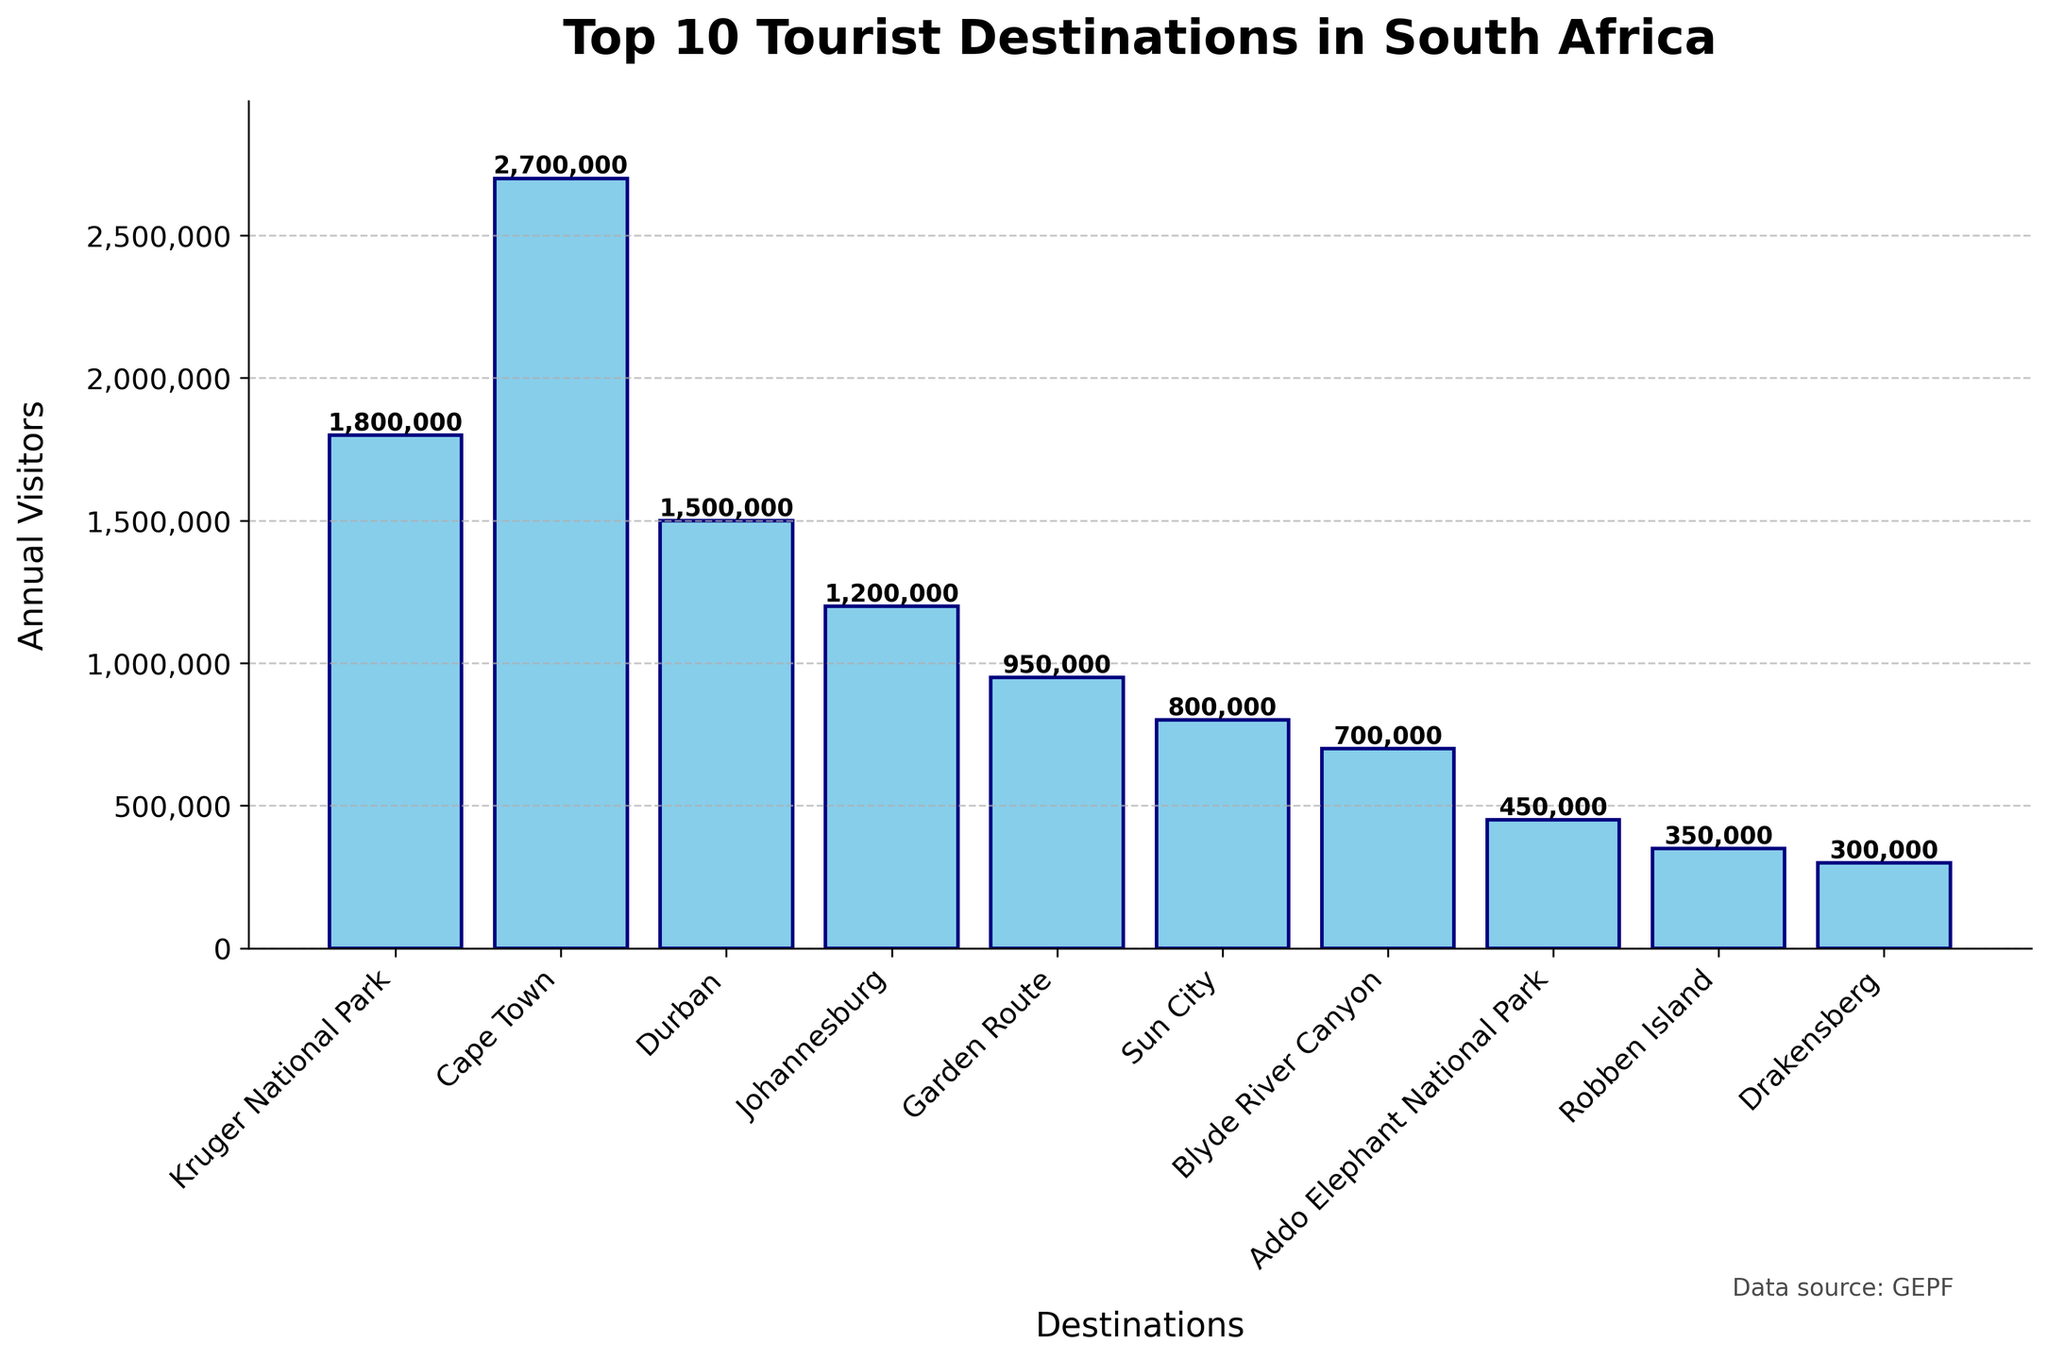What's the most visited tourist destination in South Africa according to the figure? The bar with the highest value represents the most visited tourist destination. The highest bar is for Cape Town, with 2,700,000 annual visitors.
Answer: Cape Town How many more visitors does Cape Town attract compared to Durban annually? Subtract the number of annual visitors in Durban from those in Cape Town. 2,700,000 - 1,500,000 = 1,200,000.
Answer: 1,200,000 Which destination has the least number of annual visitors? The bar with the lowest value represents the destination with the least visitors. The shortest bar corresponds to Drakensberg, with 300,000 annual visitors.
Answer: Drakensberg What is the total number of annual visitors for Kruger National Park and Sun City combined? Add the number of annual visitors for both destinations. 1,800,000 (Kruger National Park) + 800,000 (Sun City) = 2,600,000.
Answer: 2,600,000 Which two destinations have the closest number of annual visitors? Compare the values visually and find the two bars with the smallest difference in height. Blyde River Canyon (700,000) and Addo Elephant National Park (450,000) have a difference of 250,000.
Answer: Blyde River Canyon and Addo Elephant National Park Which destination has nearly half of the annual visitors compared to Cape Town? Divide Cape Town's visitors by 2, which is 2,700,000 / 2 = 1,350,000. The closest value is Durban with 1,500,000, which is near half of Cape Town's.
Answer: Durban How many destinations have more than 1 million annual visitors? Count the bars that show values greater than 1,000,000. Cape Town, Kruger National Park, Durban, and Johannesburg each have over 1,000,000 visitors.
Answer: 4 By how much does the annual visitor count of Robben Island exceed that of Drakensberg? Subtract the number of annual visitors in Drakensberg from those in Robben Island. 350,000 - 300,000 = 50,000.
Answer: 50,000 What is the average number of annual visitors for the top 5 destinations? Add the annual visitors counts of the top 5 destinations and divide by 5. (2,700,000 + 1,800,000 + 1,500,000 + 1,200,000 + 950,000) / 5 = 8,150,000 / 5 = 1,630,000.
Answer: 1,630,000 Is the number of visitors to the Garden Route closer to Sun City or Johannesburg? Subtract the number of visitors to the Garden Route from those to Sun City and Johannesburg. Garden Route is 950,000, Sun City is 800,000, and Johannesburg is 1,200,000. Differences are 950,000 - 800,000 = 150,000 and 1,200,000 - 950,000 = 250,000. 150,000 is smaller, so the Garden Route is closer to Sun City.
Answer: Sun City 